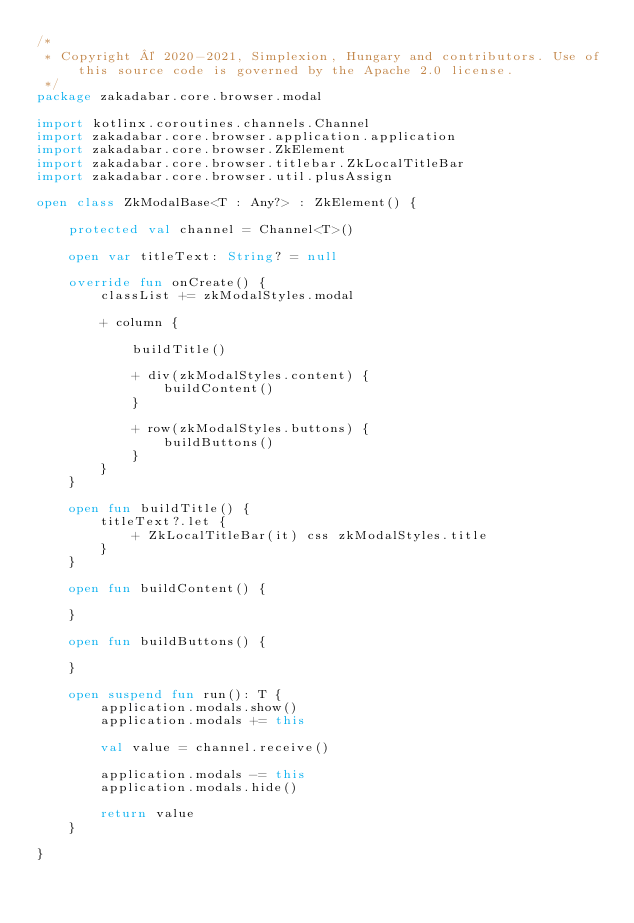Convert code to text. <code><loc_0><loc_0><loc_500><loc_500><_Kotlin_>/*
 * Copyright © 2020-2021, Simplexion, Hungary and contributors. Use of this source code is governed by the Apache 2.0 license.
 */
package zakadabar.core.browser.modal

import kotlinx.coroutines.channels.Channel
import zakadabar.core.browser.application.application
import zakadabar.core.browser.ZkElement
import zakadabar.core.browser.titlebar.ZkLocalTitleBar
import zakadabar.core.browser.util.plusAssign

open class ZkModalBase<T : Any?> : ZkElement() {

    protected val channel = Channel<T>()

    open var titleText: String? = null

    override fun onCreate() {
        classList += zkModalStyles.modal

        + column {

            buildTitle()

            + div(zkModalStyles.content) {
                buildContent()
            }

            + row(zkModalStyles.buttons) {
                buildButtons()
            }
        }
    }

    open fun buildTitle() {
        titleText?.let {
            + ZkLocalTitleBar(it) css zkModalStyles.title
        }
    }

    open fun buildContent() {

    }

    open fun buildButtons() {

    }

    open suspend fun run(): T {
        application.modals.show()
        application.modals += this

        val value = channel.receive()

        application.modals -= this
        application.modals.hide()

        return value
    }

}</code> 